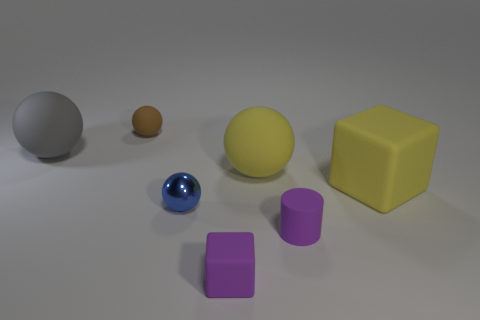Add 3 large yellow rubber objects. How many objects exist? 10 Subtract all balls. How many objects are left? 3 Add 5 small red matte cylinders. How many small red matte cylinders exist? 5 Subtract 0 red cylinders. How many objects are left? 7 Subtract all big yellow metal blocks. Subtract all tiny things. How many objects are left? 3 Add 5 gray spheres. How many gray spheres are left? 6 